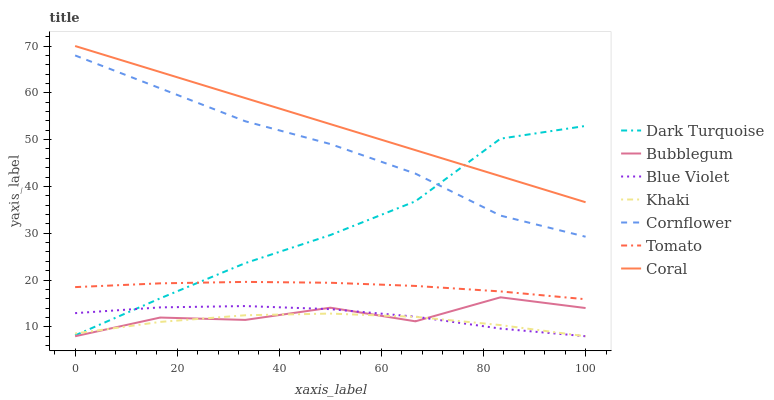Does Khaki have the minimum area under the curve?
Answer yes or no. Yes. Does Coral have the maximum area under the curve?
Answer yes or no. Yes. Does Cornflower have the minimum area under the curve?
Answer yes or no. No. Does Cornflower have the maximum area under the curve?
Answer yes or no. No. Is Coral the smoothest?
Answer yes or no. Yes. Is Bubblegum the roughest?
Answer yes or no. Yes. Is Cornflower the smoothest?
Answer yes or no. No. Is Cornflower the roughest?
Answer yes or no. No. Does Khaki have the lowest value?
Answer yes or no. Yes. Does Cornflower have the lowest value?
Answer yes or no. No. Does Coral have the highest value?
Answer yes or no. Yes. Does Cornflower have the highest value?
Answer yes or no. No. Is Blue Violet less than Cornflower?
Answer yes or no. Yes. Is Coral greater than Tomato?
Answer yes or no. Yes. Does Blue Violet intersect Khaki?
Answer yes or no. Yes. Is Blue Violet less than Khaki?
Answer yes or no. No. Is Blue Violet greater than Khaki?
Answer yes or no. No. Does Blue Violet intersect Cornflower?
Answer yes or no. No. 